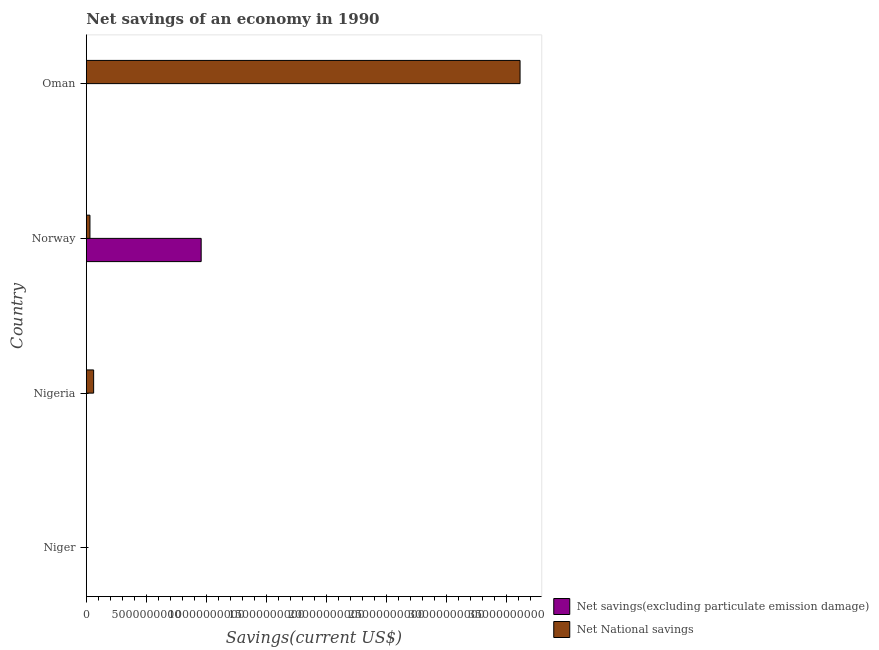How many bars are there on the 4th tick from the top?
Offer a terse response. 0. How many bars are there on the 3rd tick from the bottom?
Make the answer very short. 2. What is the label of the 3rd group of bars from the top?
Provide a succinct answer. Nigeria. In how many cases, is the number of bars for a given country not equal to the number of legend labels?
Your answer should be very brief. 3. Across all countries, what is the maximum net savings(excluding particulate emission damage)?
Keep it short and to the point. 9.58e+09. Across all countries, what is the minimum net national savings?
Keep it short and to the point. 0. In which country was the net national savings maximum?
Give a very brief answer. Oman. What is the total net savings(excluding particulate emission damage) in the graph?
Make the answer very short. 9.58e+09. What is the difference between the net national savings in Nigeria and that in Oman?
Offer a terse response. -3.56e+1. What is the difference between the net savings(excluding particulate emission damage) in Niger and the net national savings in Oman?
Offer a terse response. -3.62e+1. What is the average net national savings per country?
Keep it short and to the point. 9.27e+09. What is the difference between the net savings(excluding particulate emission damage) and net national savings in Norway?
Provide a succinct answer. 9.28e+09. What is the ratio of the net national savings in Nigeria to that in Oman?
Offer a very short reply. 0.02. What is the difference between the highest and the second highest net national savings?
Keep it short and to the point. 3.56e+1. What is the difference between the highest and the lowest net savings(excluding particulate emission damage)?
Your response must be concise. 9.58e+09. How many bars are there?
Your response must be concise. 4. How many countries are there in the graph?
Your answer should be very brief. 4. What is the title of the graph?
Your answer should be very brief. Net savings of an economy in 1990. Does "Register a business" appear as one of the legend labels in the graph?
Provide a short and direct response. No. What is the label or title of the X-axis?
Your answer should be compact. Savings(current US$). What is the Savings(current US$) in Net National savings in Niger?
Your answer should be compact. 0. What is the Savings(current US$) in Net savings(excluding particulate emission damage) in Nigeria?
Your response must be concise. 0. What is the Savings(current US$) in Net National savings in Nigeria?
Offer a very short reply. 6.08e+08. What is the Savings(current US$) in Net savings(excluding particulate emission damage) in Norway?
Ensure brevity in your answer.  9.58e+09. What is the Savings(current US$) of Net National savings in Norway?
Offer a terse response. 3.01e+08. What is the Savings(current US$) in Net savings(excluding particulate emission damage) in Oman?
Provide a short and direct response. 0. What is the Savings(current US$) in Net National savings in Oman?
Provide a succinct answer. 3.62e+1. Across all countries, what is the maximum Savings(current US$) of Net savings(excluding particulate emission damage)?
Provide a succinct answer. 9.58e+09. Across all countries, what is the maximum Savings(current US$) of Net National savings?
Ensure brevity in your answer.  3.62e+1. What is the total Savings(current US$) in Net savings(excluding particulate emission damage) in the graph?
Your answer should be compact. 9.58e+09. What is the total Savings(current US$) of Net National savings in the graph?
Give a very brief answer. 3.71e+1. What is the difference between the Savings(current US$) of Net National savings in Nigeria and that in Norway?
Give a very brief answer. 3.08e+08. What is the difference between the Savings(current US$) of Net National savings in Nigeria and that in Oman?
Make the answer very short. -3.56e+1. What is the difference between the Savings(current US$) in Net National savings in Norway and that in Oman?
Your response must be concise. -3.59e+1. What is the difference between the Savings(current US$) in Net savings(excluding particulate emission damage) in Norway and the Savings(current US$) in Net National savings in Oman?
Make the answer very short. -2.66e+1. What is the average Savings(current US$) in Net savings(excluding particulate emission damage) per country?
Give a very brief answer. 2.39e+09. What is the average Savings(current US$) of Net National savings per country?
Ensure brevity in your answer.  9.27e+09. What is the difference between the Savings(current US$) in Net savings(excluding particulate emission damage) and Savings(current US$) in Net National savings in Norway?
Your answer should be compact. 9.28e+09. What is the ratio of the Savings(current US$) in Net National savings in Nigeria to that in Norway?
Your response must be concise. 2.02. What is the ratio of the Savings(current US$) in Net National savings in Nigeria to that in Oman?
Your answer should be compact. 0.02. What is the ratio of the Savings(current US$) in Net National savings in Norway to that in Oman?
Keep it short and to the point. 0.01. What is the difference between the highest and the second highest Savings(current US$) in Net National savings?
Keep it short and to the point. 3.56e+1. What is the difference between the highest and the lowest Savings(current US$) of Net savings(excluding particulate emission damage)?
Keep it short and to the point. 9.58e+09. What is the difference between the highest and the lowest Savings(current US$) of Net National savings?
Offer a very short reply. 3.62e+1. 